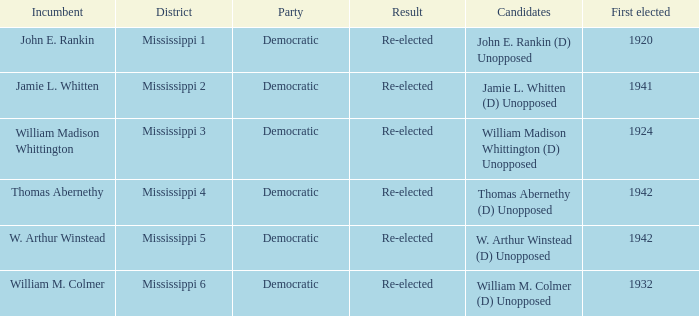What candidates are from mississippi 6? William M. Colmer (D) Unopposed. 